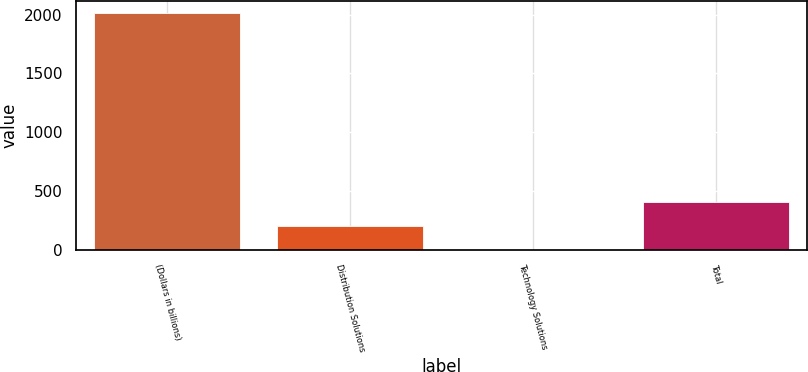<chart> <loc_0><loc_0><loc_500><loc_500><bar_chart><fcel>(Dollars in billions)<fcel>Distribution Solutions<fcel>Technology Solutions<fcel>Total<nl><fcel>2014<fcel>203.2<fcel>2<fcel>404.4<nl></chart> 